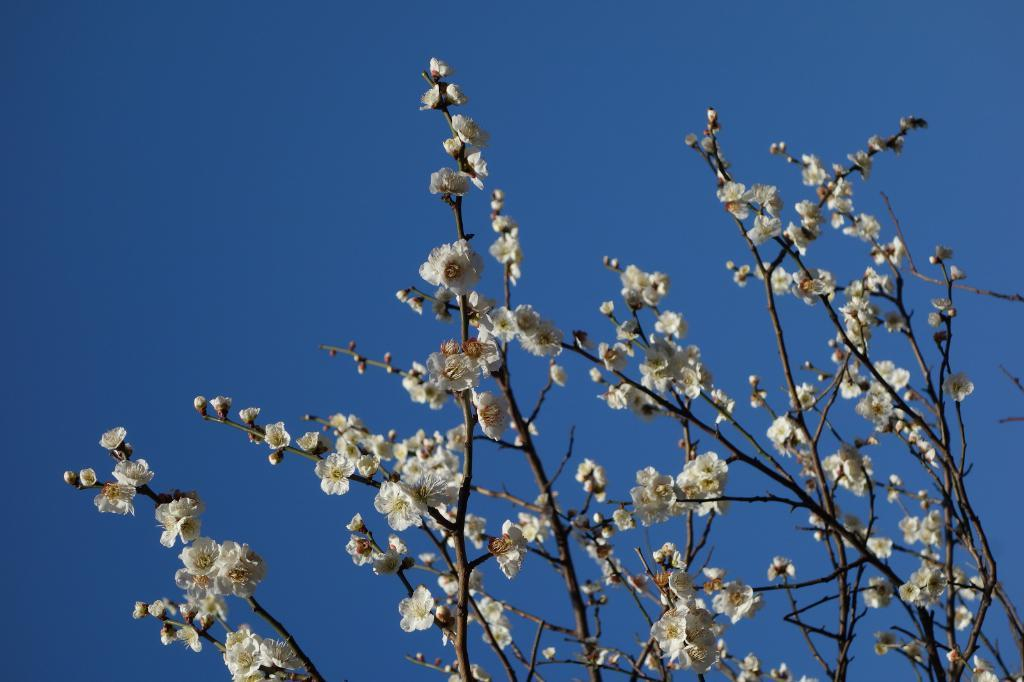What type of natural element is present in the image? There is a tree in the image. What color is the sky in the image? The sky is blue in the image. What type of whip is hanging from the tree in the image? There is no whip present in the image; it only features a tree and a blue sky. What type of steel structure can be seen supporting the tree in the image? There is no steel structure present in the image; the tree is standing on its own. 